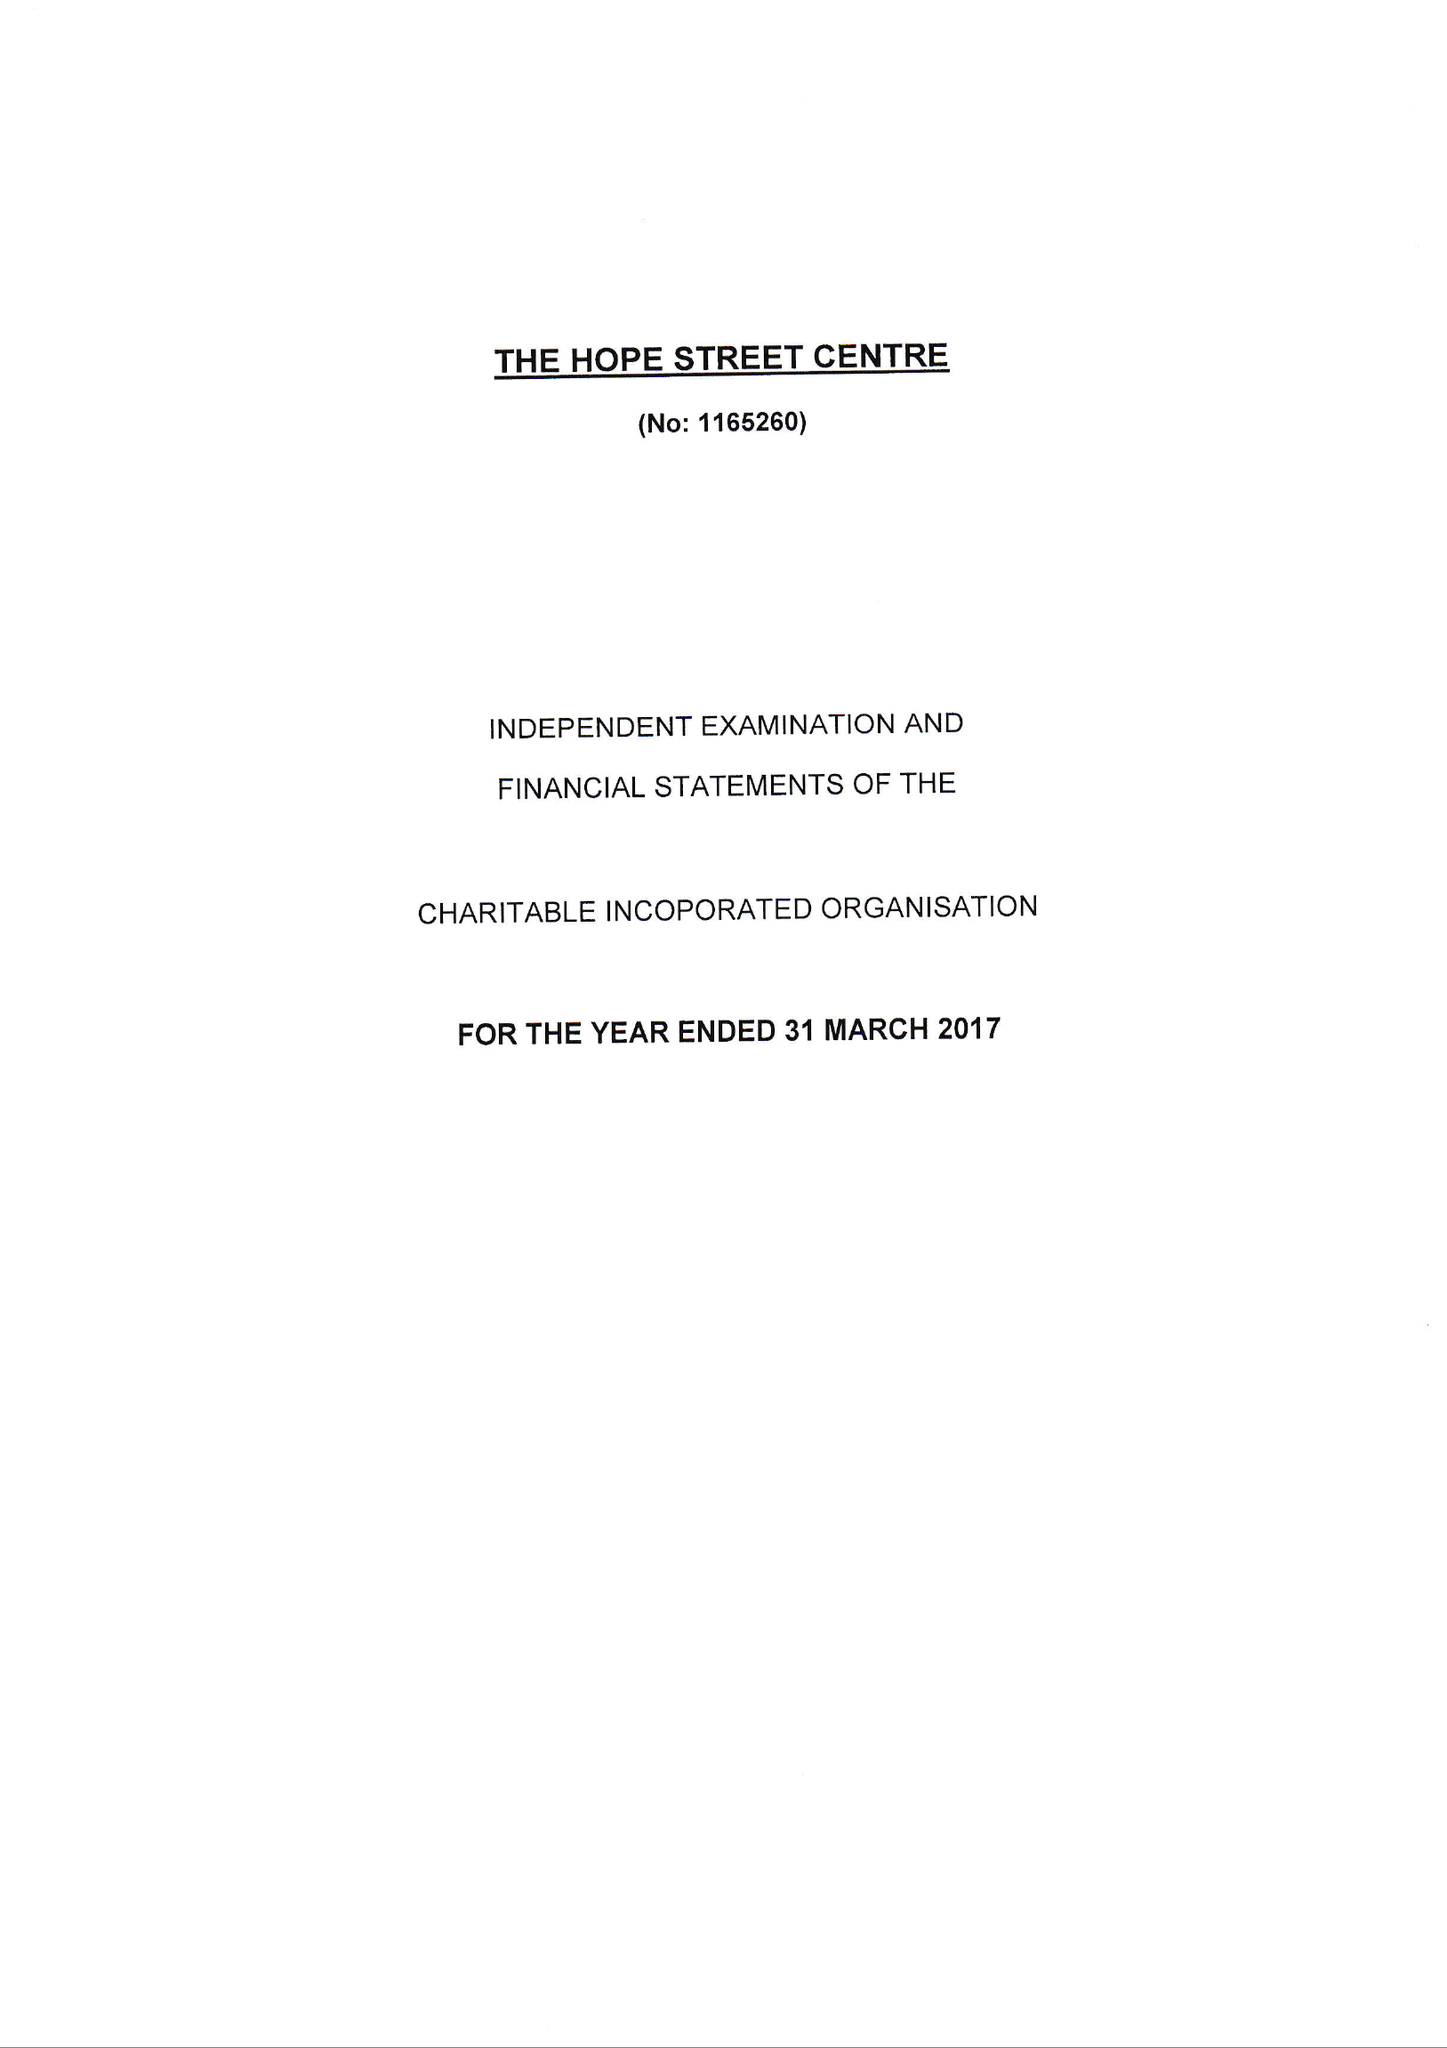What is the value for the spending_annually_in_british_pounds?
Answer the question using a single word or phrase. 69451.00 